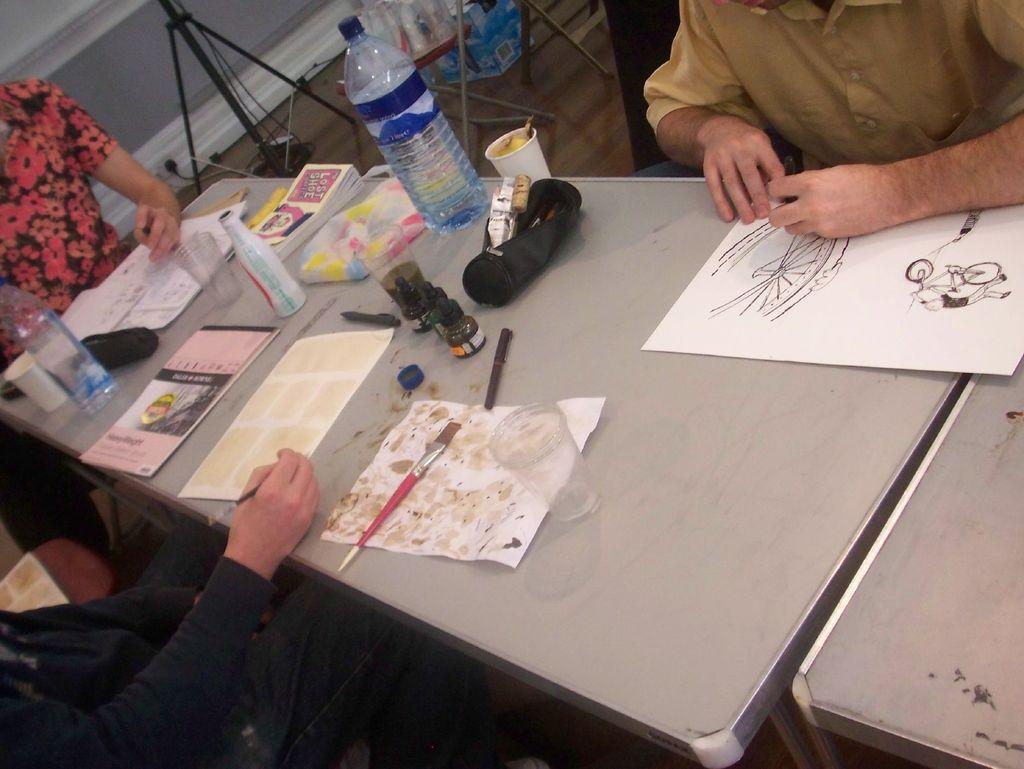In one or two sentences, can you explain what this image depicts? In the image we can see there are three persons sitting on chair. This is a table on the table we can see paper, glass, paint brush, water bottle and a book. 